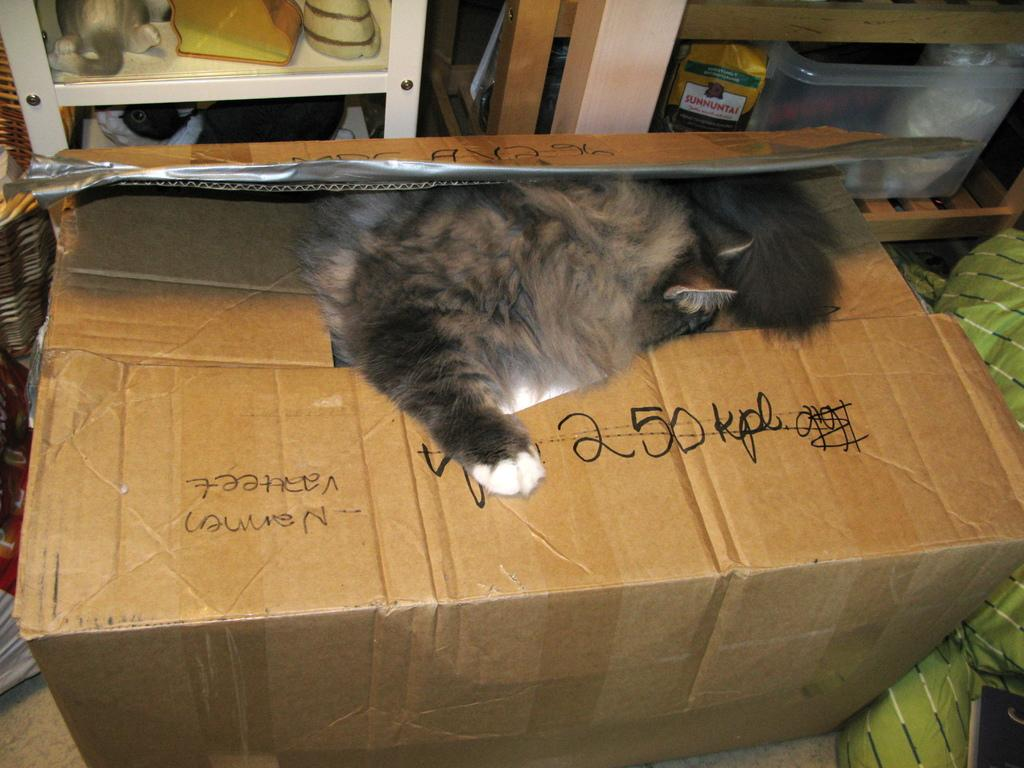<image>
Relay a brief, clear account of the picture shown. A cat sleeps on top of a box with 250 in black marker. 